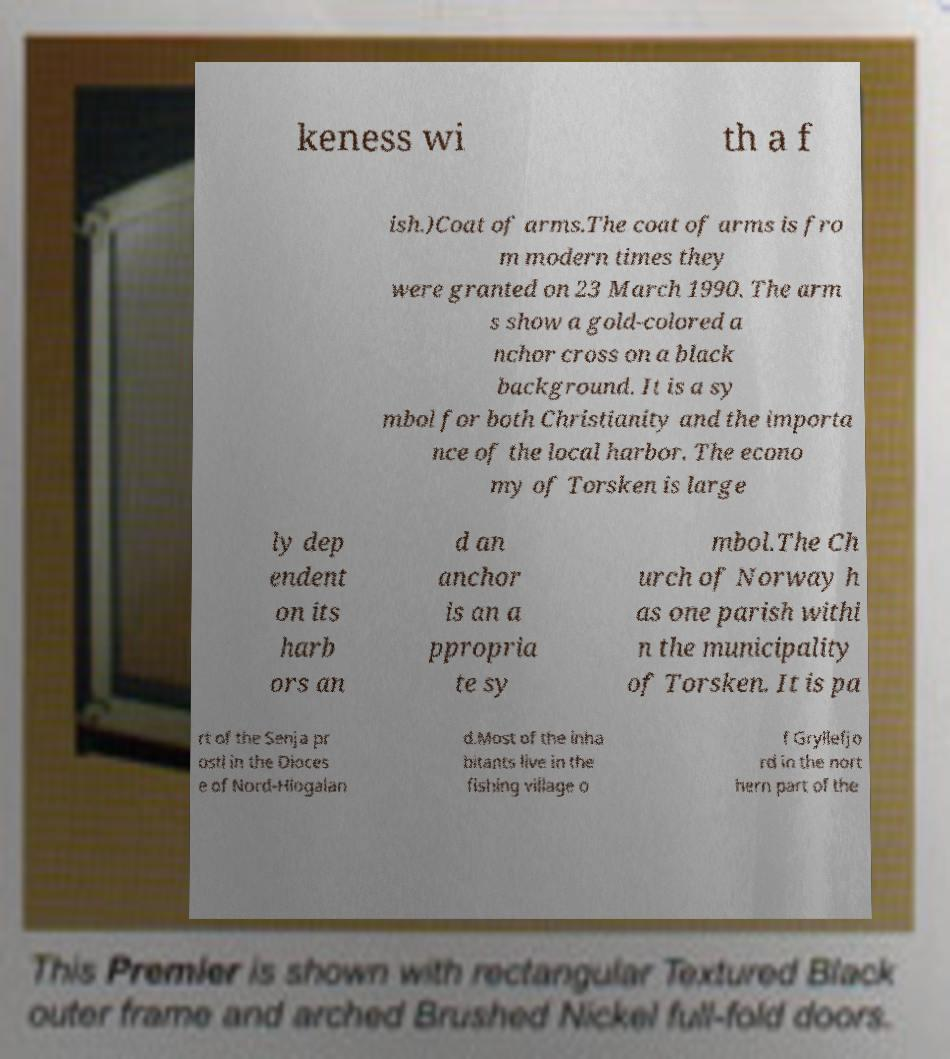Could you extract and type out the text from this image? keness wi th a f ish.)Coat of arms.The coat of arms is fro m modern times they were granted on 23 March 1990. The arm s show a gold-colored a nchor cross on a black background. It is a sy mbol for both Christianity and the importa nce of the local harbor. The econo my of Torsken is large ly dep endent on its harb ors an d an anchor is an a ppropria te sy mbol.The Ch urch of Norway h as one parish withi n the municipality of Torsken. It is pa rt of the Senja pr osti in the Dioces e of Nord-Hlogalan d.Most of the inha bitants live in the fishing village o f Gryllefjo rd in the nort hern part of the 